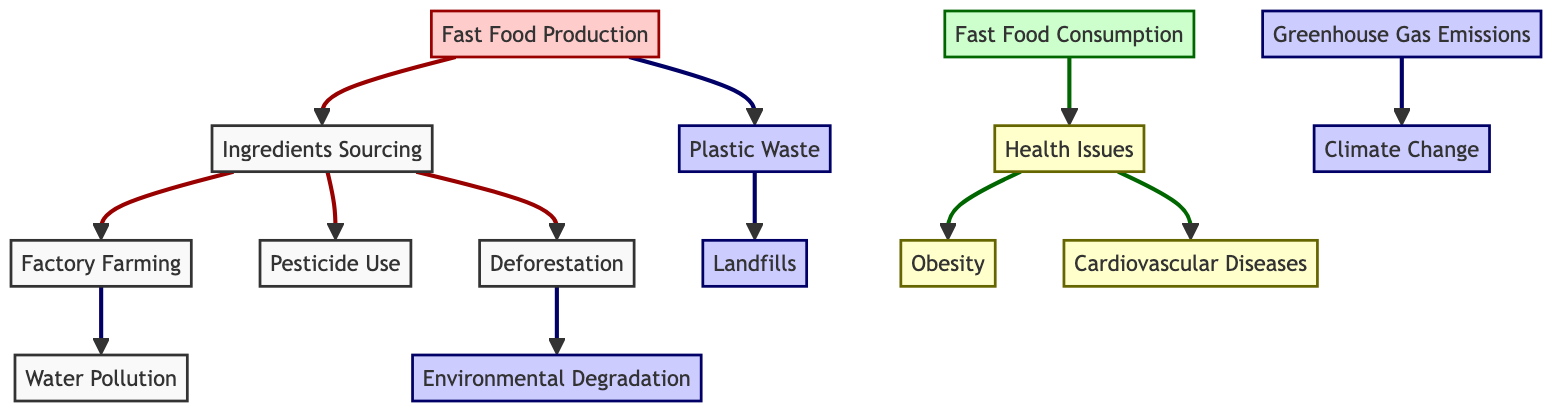What is the first step in the food chain? The diagram starts with "Fast Food Production" as the first node, indicating that it is the beginning of the food chain process.
Answer: Fast Food Production How many health-related issues are identified in the diagram? The diagram includes three specific health-related issues: Obesity, Cardiovascular Diseases, and Health Issues. Therefore, the total number is three.
Answer: 3 What environmental consequence is linked to Deforestation? The node "Deforestation" directly connects to the node "Environmental Degradation," indicating that deforestation results in environmental degradation.
Answer: Environmental Degradation Which node indicates the impact of Fast Food Consumption on health? The node "Fast Food Consumption" points to the node "Health Issues," demonstrating the effect that fast food consumption has on health.
Answer: Health Issues What is the relationship between Greenhouse Gas Emissions and Climate Change? The arrow from "Greenhouse Gas Emissions" to "Climate Change" signifies that greenhouse gas emissions contribute to climate change, establishing a direct relationship.
Answer: Climate Change How many environmental issues are identified in the diagram? The diagram lists four environmental issues: Environmental Degradation, Greenhouse Gas Emissions, Plastic Waste, and Climate Change. Summing these, we have four environmental issues.
Answer: 4 What is the impact of Pesticide Use according to the diagram? The "Pesticide Use" node does not have a direct output node indicating its consequences, but it connects to "Ingredients Sourcing," suggesting an indirect influence on the food production chain.
Answer: Ingredients Sourcing What is the connection between Plastic Waste and Landfills? The diagram shows that "Plastic Waste" is directed towards "Landfills," pointing out the outcome of plastic waste accumulation.
Answer: Landfills Which health issue is directly linked to Fast Food Consumption? The node "Fast Food Consumption" directly leads to "Health Issues," establishing that consumption directly affects health.
Answer: Health Issues 